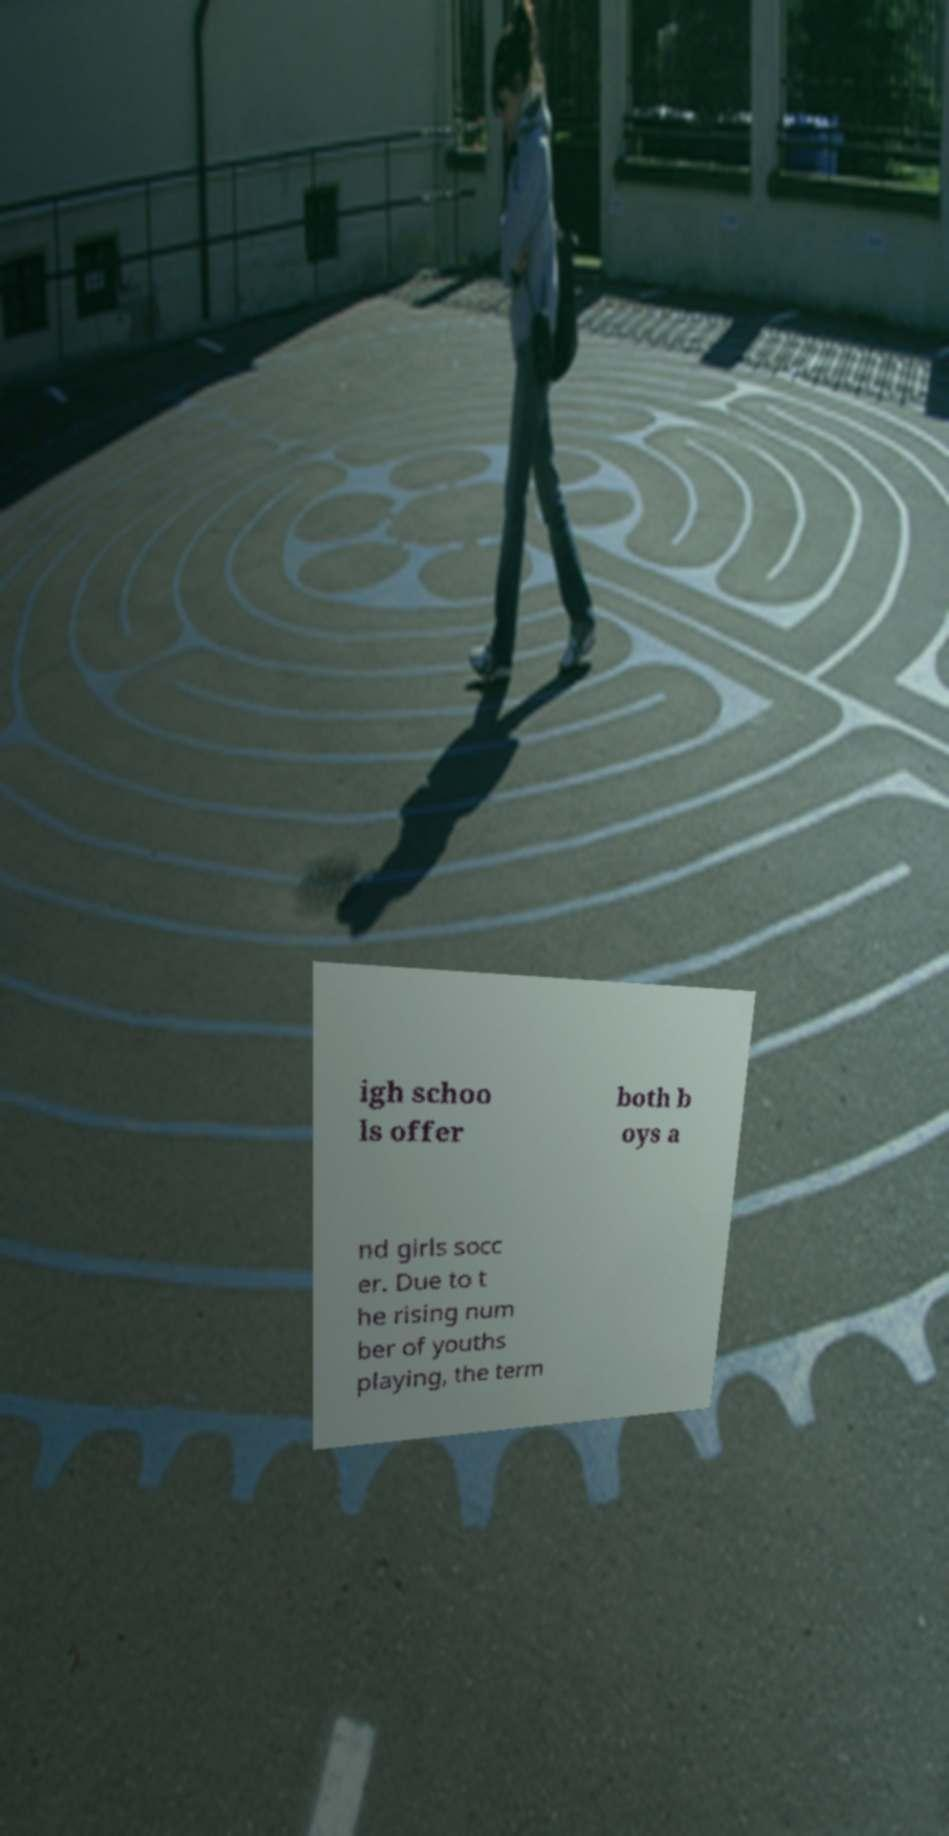I need the written content from this picture converted into text. Can you do that? igh schoo ls offer both b oys a nd girls socc er. Due to t he rising num ber of youths playing, the term 